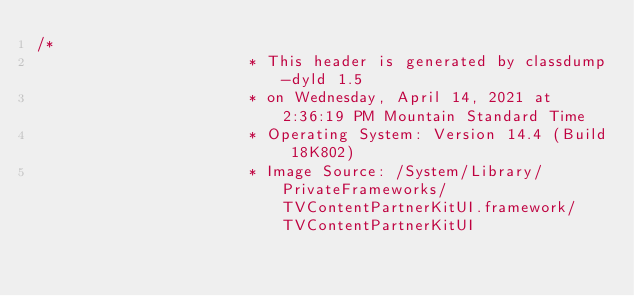<code> <loc_0><loc_0><loc_500><loc_500><_C_>/*
                       * This header is generated by classdump-dyld 1.5
                       * on Wednesday, April 14, 2021 at 2:36:19 PM Mountain Standard Time
                       * Operating System: Version 14.4 (Build 18K802)
                       * Image Source: /System/Library/PrivateFrameworks/TVContentPartnerKitUI.framework/TVContentPartnerKitUI</code> 